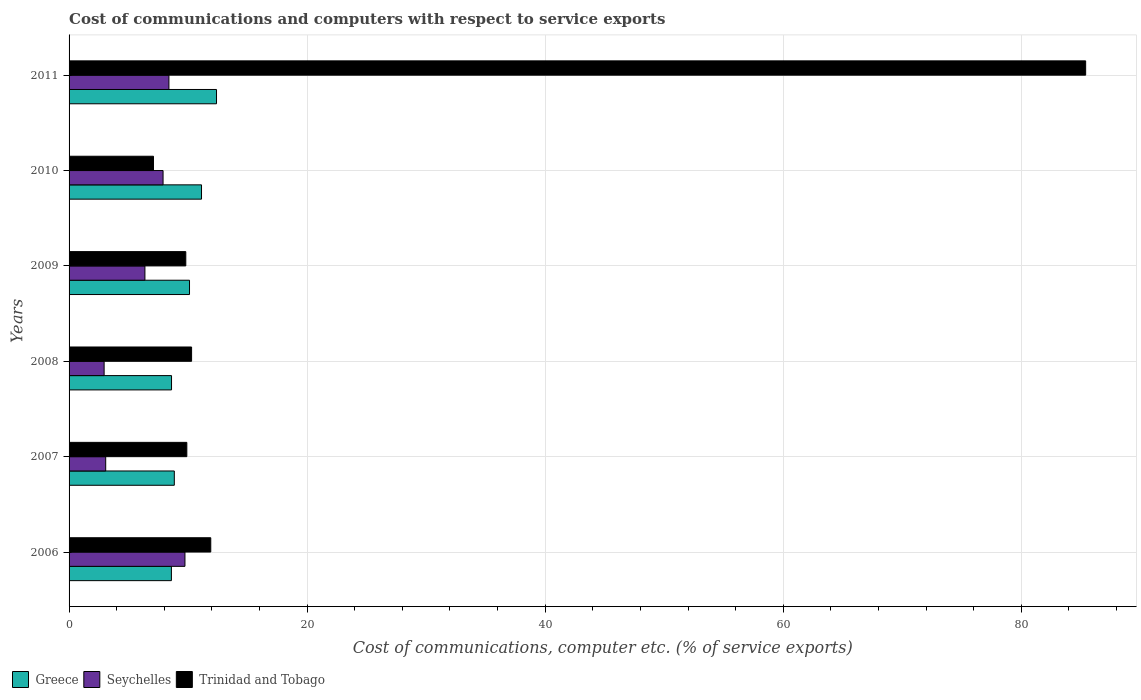How many groups of bars are there?
Make the answer very short. 6. Are the number of bars on each tick of the Y-axis equal?
Your answer should be compact. Yes. How many bars are there on the 6th tick from the top?
Your response must be concise. 3. How many bars are there on the 6th tick from the bottom?
Offer a very short reply. 3. What is the cost of communications and computers in Trinidad and Tobago in 2008?
Your answer should be compact. 10.29. Across all years, what is the maximum cost of communications and computers in Trinidad and Tobago?
Offer a very short reply. 85.41. Across all years, what is the minimum cost of communications and computers in Seychelles?
Make the answer very short. 2.95. In which year was the cost of communications and computers in Trinidad and Tobago maximum?
Provide a short and direct response. 2011. In which year was the cost of communications and computers in Greece minimum?
Your answer should be very brief. 2006. What is the total cost of communications and computers in Trinidad and Tobago in the graph?
Make the answer very short. 134.4. What is the difference between the cost of communications and computers in Trinidad and Tobago in 2006 and that in 2007?
Make the answer very short. 2.01. What is the difference between the cost of communications and computers in Greece in 2009 and the cost of communications and computers in Trinidad and Tobago in 2008?
Provide a succinct answer. -0.17. What is the average cost of communications and computers in Greece per year?
Provide a succinct answer. 9.95. In the year 2008, what is the difference between the cost of communications and computers in Seychelles and cost of communications and computers in Greece?
Your answer should be compact. -5.66. In how many years, is the cost of communications and computers in Greece greater than 60 %?
Your answer should be very brief. 0. What is the ratio of the cost of communications and computers in Trinidad and Tobago in 2006 to that in 2010?
Your answer should be compact. 1.68. What is the difference between the highest and the second highest cost of communications and computers in Seychelles?
Keep it short and to the point. 1.35. What is the difference between the highest and the lowest cost of communications and computers in Greece?
Ensure brevity in your answer.  3.79. In how many years, is the cost of communications and computers in Seychelles greater than the average cost of communications and computers in Seychelles taken over all years?
Your answer should be very brief. 3. What does the 1st bar from the top in 2011 represents?
Make the answer very short. Trinidad and Tobago. What does the 2nd bar from the bottom in 2011 represents?
Your response must be concise. Seychelles. Is it the case that in every year, the sum of the cost of communications and computers in Seychelles and cost of communications and computers in Greece is greater than the cost of communications and computers in Trinidad and Tobago?
Provide a short and direct response. No. How many bars are there?
Your answer should be compact. 18. Are all the bars in the graph horizontal?
Provide a short and direct response. Yes. How many years are there in the graph?
Keep it short and to the point. 6. Are the values on the major ticks of X-axis written in scientific E-notation?
Your answer should be very brief. No. Does the graph contain grids?
Provide a succinct answer. Yes. Where does the legend appear in the graph?
Provide a succinct answer. Bottom left. How are the legend labels stacked?
Offer a very short reply. Horizontal. What is the title of the graph?
Keep it short and to the point. Cost of communications and computers with respect to service exports. Does "Maldives" appear as one of the legend labels in the graph?
Give a very brief answer. No. What is the label or title of the X-axis?
Offer a terse response. Cost of communications, computer etc. (% of service exports). What is the label or title of the Y-axis?
Ensure brevity in your answer.  Years. What is the Cost of communications, computer etc. (% of service exports) in Greece in 2006?
Keep it short and to the point. 8.6. What is the Cost of communications, computer etc. (% of service exports) of Seychelles in 2006?
Your answer should be very brief. 9.74. What is the Cost of communications, computer etc. (% of service exports) in Trinidad and Tobago in 2006?
Provide a succinct answer. 11.9. What is the Cost of communications, computer etc. (% of service exports) of Greece in 2007?
Your answer should be compact. 8.84. What is the Cost of communications, computer etc. (% of service exports) in Seychelles in 2007?
Your response must be concise. 3.08. What is the Cost of communications, computer etc. (% of service exports) of Trinidad and Tobago in 2007?
Provide a succinct answer. 9.89. What is the Cost of communications, computer etc. (% of service exports) of Greece in 2008?
Offer a very short reply. 8.61. What is the Cost of communications, computer etc. (% of service exports) of Seychelles in 2008?
Provide a short and direct response. 2.95. What is the Cost of communications, computer etc. (% of service exports) in Trinidad and Tobago in 2008?
Offer a very short reply. 10.29. What is the Cost of communications, computer etc. (% of service exports) of Greece in 2009?
Make the answer very short. 10.12. What is the Cost of communications, computer etc. (% of service exports) of Seychelles in 2009?
Keep it short and to the point. 6.37. What is the Cost of communications, computer etc. (% of service exports) in Trinidad and Tobago in 2009?
Your answer should be very brief. 9.81. What is the Cost of communications, computer etc. (% of service exports) in Greece in 2010?
Make the answer very short. 11.13. What is the Cost of communications, computer etc. (% of service exports) of Seychelles in 2010?
Your response must be concise. 7.9. What is the Cost of communications, computer etc. (% of service exports) in Trinidad and Tobago in 2010?
Your answer should be compact. 7.09. What is the Cost of communications, computer etc. (% of service exports) in Greece in 2011?
Give a very brief answer. 12.39. What is the Cost of communications, computer etc. (% of service exports) in Seychelles in 2011?
Offer a very short reply. 8.39. What is the Cost of communications, computer etc. (% of service exports) in Trinidad and Tobago in 2011?
Your response must be concise. 85.41. Across all years, what is the maximum Cost of communications, computer etc. (% of service exports) in Greece?
Your answer should be compact. 12.39. Across all years, what is the maximum Cost of communications, computer etc. (% of service exports) in Seychelles?
Make the answer very short. 9.74. Across all years, what is the maximum Cost of communications, computer etc. (% of service exports) of Trinidad and Tobago?
Your answer should be compact. 85.41. Across all years, what is the minimum Cost of communications, computer etc. (% of service exports) in Greece?
Offer a terse response. 8.6. Across all years, what is the minimum Cost of communications, computer etc. (% of service exports) of Seychelles?
Your answer should be compact. 2.95. Across all years, what is the minimum Cost of communications, computer etc. (% of service exports) of Trinidad and Tobago?
Your answer should be compact. 7.09. What is the total Cost of communications, computer etc. (% of service exports) of Greece in the graph?
Offer a terse response. 59.68. What is the total Cost of communications, computer etc. (% of service exports) of Seychelles in the graph?
Offer a very short reply. 38.42. What is the total Cost of communications, computer etc. (% of service exports) in Trinidad and Tobago in the graph?
Keep it short and to the point. 134.4. What is the difference between the Cost of communications, computer etc. (% of service exports) of Greece in 2006 and that in 2007?
Your answer should be very brief. -0.24. What is the difference between the Cost of communications, computer etc. (% of service exports) of Seychelles in 2006 and that in 2007?
Your response must be concise. 6.66. What is the difference between the Cost of communications, computer etc. (% of service exports) in Trinidad and Tobago in 2006 and that in 2007?
Your answer should be very brief. 2.01. What is the difference between the Cost of communications, computer etc. (% of service exports) in Greece in 2006 and that in 2008?
Provide a short and direct response. -0.01. What is the difference between the Cost of communications, computer etc. (% of service exports) in Seychelles in 2006 and that in 2008?
Your answer should be very brief. 6.79. What is the difference between the Cost of communications, computer etc. (% of service exports) of Trinidad and Tobago in 2006 and that in 2008?
Keep it short and to the point. 1.61. What is the difference between the Cost of communications, computer etc. (% of service exports) of Greece in 2006 and that in 2009?
Keep it short and to the point. -1.52. What is the difference between the Cost of communications, computer etc. (% of service exports) of Seychelles in 2006 and that in 2009?
Give a very brief answer. 3.36. What is the difference between the Cost of communications, computer etc. (% of service exports) of Trinidad and Tobago in 2006 and that in 2009?
Keep it short and to the point. 2.1. What is the difference between the Cost of communications, computer etc. (% of service exports) in Greece in 2006 and that in 2010?
Offer a very short reply. -2.53. What is the difference between the Cost of communications, computer etc. (% of service exports) of Seychelles in 2006 and that in 2010?
Make the answer very short. 1.84. What is the difference between the Cost of communications, computer etc. (% of service exports) of Trinidad and Tobago in 2006 and that in 2010?
Make the answer very short. 4.81. What is the difference between the Cost of communications, computer etc. (% of service exports) of Greece in 2006 and that in 2011?
Your answer should be compact. -3.79. What is the difference between the Cost of communications, computer etc. (% of service exports) of Seychelles in 2006 and that in 2011?
Your answer should be compact. 1.35. What is the difference between the Cost of communications, computer etc. (% of service exports) of Trinidad and Tobago in 2006 and that in 2011?
Keep it short and to the point. -73.5. What is the difference between the Cost of communications, computer etc. (% of service exports) of Greece in 2007 and that in 2008?
Provide a succinct answer. 0.23. What is the difference between the Cost of communications, computer etc. (% of service exports) in Seychelles in 2007 and that in 2008?
Keep it short and to the point. 0.13. What is the difference between the Cost of communications, computer etc. (% of service exports) of Trinidad and Tobago in 2007 and that in 2008?
Your response must be concise. -0.4. What is the difference between the Cost of communications, computer etc. (% of service exports) in Greece in 2007 and that in 2009?
Offer a terse response. -1.28. What is the difference between the Cost of communications, computer etc. (% of service exports) in Seychelles in 2007 and that in 2009?
Keep it short and to the point. -3.29. What is the difference between the Cost of communications, computer etc. (% of service exports) in Trinidad and Tobago in 2007 and that in 2009?
Ensure brevity in your answer.  0.09. What is the difference between the Cost of communications, computer etc. (% of service exports) in Greece in 2007 and that in 2010?
Ensure brevity in your answer.  -2.29. What is the difference between the Cost of communications, computer etc. (% of service exports) in Seychelles in 2007 and that in 2010?
Provide a succinct answer. -4.82. What is the difference between the Cost of communications, computer etc. (% of service exports) of Trinidad and Tobago in 2007 and that in 2010?
Your answer should be very brief. 2.8. What is the difference between the Cost of communications, computer etc. (% of service exports) of Greece in 2007 and that in 2011?
Offer a very short reply. -3.55. What is the difference between the Cost of communications, computer etc. (% of service exports) in Seychelles in 2007 and that in 2011?
Ensure brevity in your answer.  -5.31. What is the difference between the Cost of communications, computer etc. (% of service exports) in Trinidad and Tobago in 2007 and that in 2011?
Provide a short and direct response. -75.52. What is the difference between the Cost of communications, computer etc. (% of service exports) of Greece in 2008 and that in 2009?
Provide a short and direct response. -1.51. What is the difference between the Cost of communications, computer etc. (% of service exports) of Seychelles in 2008 and that in 2009?
Offer a very short reply. -3.43. What is the difference between the Cost of communications, computer etc. (% of service exports) in Trinidad and Tobago in 2008 and that in 2009?
Keep it short and to the point. 0.49. What is the difference between the Cost of communications, computer etc. (% of service exports) of Greece in 2008 and that in 2010?
Your answer should be very brief. -2.52. What is the difference between the Cost of communications, computer etc. (% of service exports) in Seychelles in 2008 and that in 2010?
Your response must be concise. -4.95. What is the difference between the Cost of communications, computer etc. (% of service exports) of Trinidad and Tobago in 2008 and that in 2010?
Offer a terse response. 3.2. What is the difference between the Cost of communications, computer etc. (% of service exports) in Greece in 2008 and that in 2011?
Give a very brief answer. -3.78. What is the difference between the Cost of communications, computer etc. (% of service exports) of Seychelles in 2008 and that in 2011?
Provide a succinct answer. -5.44. What is the difference between the Cost of communications, computer etc. (% of service exports) of Trinidad and Tobago in 2008 and that in 2011?
Provide a short and direct response. -75.12. What is the difference between the Cost of communications, computer etc. (% of service exports) in Greece in 2009 and that in 2010?
Your answer should be compact. -1.01. What is the difference between the Cost of communications, computer etc. (% of service exports) of Seychelles in 2009 and that in 2010?
Keep it short and to the point. -1.52. What is the difference between the Cost of communications, computer etc. (% of service exports) in Trinidad and Tobago in 2009 and that in 2010?
Ensure brevity in your answer.  2.71. What is the difference between the Cost of communications, computer etc. (% of service exports) of Greece in 2009 and that in 2011?
Give a very brief answer. -2.27. What is the difference between the Cost of communications, computer etc. (% of service exports) in Seychelles in 2009 and that in 2011?
Ensure brevity in your answer.  -2.02. What is the difference between the Cost of communications, computer etc. (% of service exports) in Trinidad and Tobago in 2009 and that in 2011?
Your response must be concise. -75.6. What is the difference between the Cost of communications, computer etc. (% of service exports) of Greece in 2010 and that in 2011?
Offer a very short reply. -1.26. What is the difference between the Cost of communications, computer etc. (% of service exports) of Seychelles in 2010 and that in 2011?
Your response must be concise. -0.49. What is the difference between the Cost of communications, computer etc. (% of service exports) of Trinidad and Tobago in 2010 and that in 2011?
Offer a terse response. -78.32. What is the difference between the Cost of communications, computer etc. (% of service exports) in Greece in 2006 and the Cost of communications, computer etc. (% of service exports) in Seychelles in 2007?
Keep it short and to the point. 5.52. What is the difference between the Cost of communications, computer etc. (% of service exports) of Greece in 2006 and the Cost of communications, computer etc. (% of service exports) of Trinidad and Tobago in 2007?
Your answer should be compact. -1.3. What is the difference between the Cost of communications, computer etc. (% of service exports) of Seychelles in 2006 and the Cost of communications, computer etc. (% of service exports) of Trinidad and Tobago in 2007?
Provide a short and direct response. -0.16. What is the difference between the Cost of communications, computer etc. (% of service exports) in Greece in 2006 and the Cost of communications, computer etc. (% of service exports) in Seychelles in 2008?
Give a very brief answer. 5.65. What is the difference between the Cost of communications, computer etc. (% of service exports) in Greece in 2006 and the Cost of communications, computer etc. (% of service exports) in Trinidad and Tobago in 2008?
Your answer should be very brief. -1.7. What is the difference between the Cost of communications, computer etc. (% of service exports) of Seychelles in 2006 and the Cost of communications, computer etc. (% of service exports) of Trinidad and Tobago in 2008?
Keep it short and to the point. -0.56. What is the difference between the Cost of communications, computer etc. (% of service exports) of Greece in 2006 and the Cost of communications, computer etc. (% of service exports) of Seychelles in 2009?
Your answer should be very brief. 2.22. What is the difference between the Cost of communications, computer etc. (% of service exports) in Greece in 2006 and the Cost of communications, computer etc. (% of service exports) in Trinidad and Tobago in 2009?
Provide a short and direct response. -1.21. What is the difference between the Cost of communications, computer etc. (% of service exports) of Seychelles in 2006 and the Cost of communications, computer etc. (% of service exports) of Trinidad and Tobago in 2009?
Ensure brevity in your answer.  -0.07. What is the difference between the Cost of communications, computer etc. (% of service exports) of Greece in 2006 and the Cost of communications, computer etc. (% of service exports) of Seychelles in 2010?
Provide a short and direct response. 0.7. What is the difference between the Cost of communications, computer etc. (% of service exports) in Greece in 2006 and the Cost of communications, computer etc. (% of service exports) in Trinidad and Tobago in 2010?
Your answer should be very brief. 1.51. What is the difference between the Cost of communications, computer etc. (% of service exports) in Seychelles in 2006 and the Cost of communications, computer etc. (% of service exports) in Trinidad and Tobago in 2010?
Make the answer very short. 2.64. What is the difference between the Cost of communications, computer etc. (% of service exports) of Greece in 2006 and the Cost of communications, computer etc. (% of service exports) of Seychelles in 2011?
Ensure brevity in your answer.  0.21. What is the difference between the Cost of communications, computer etc. (% of service exports) in Greece in 2006 and the Cost of communications, computer etc. (% of service exports) in Trinidad and Tobago in 2011?
Your answer should be very brief. -76.81. What is the difference between the Cost of communications, computer etc. (% of service exports) in Seychelles in 2006 and the Cost of communications, computer etc. (% of service exports) in Trinidad and Tobago in 2011?
Your response must be concise. -75.67. What is the difference between the Cost of communications, computer etc. (% of service exports) in Greece in 2007 and the Cost of communications, computer etc. (% of service exports) in Seychelles in 2008?
Your answer should be compact. 5.9. What is the difference between the Cost of communications, computer etc. (% of service exports) of Greece in 2007 and the Cost of communications, computer etc. (% of service exports) of Trinidad and Tobago in 2008?
Your response must be concise. -1.45. What is the difference between the Cost of communications, computer etc. (% of service exports) in Seychelles in 2007 and the Cost of communications, computer etc. (% of service exports) in Trinidad and Tobago in 2008?
Give a very brief answer. -7.22. What is the difference between the Cost of communications, computer etc. (% of service exports) of Greece in 2007 and the Cost of communications, computer etc. (% of service exports) of Seychelles in 2009?
Your answer should be compact. 2.47. What is the difference between the Cost of communications, computer etc. (% of service exports) in Greece in 2007 and the Cost of communications, computer etc. (% of service exports) in Trinidad and Tobago in 2009?
Make the answer very short. -0.97. What is the difference between the Cost of communications, computer etc. (% of service exports) in Seychelles in 2007 and the Cost of communications, computer etc. (% of service exports) in Trinidad and Tobago in 2009?
Provide a succinct answer. -6.73. What is the difference between the Cost of communications, computer etc. (% of service exports) of Greece in 2007 and the Cost of communications, computer etc. (% of service exports) of Seychelles in 2010?
Ensure brevity in your answer.  0.94. What is the difference between the Cost of communications, computer etc. (% of service exports) in Greece in 2007 and the Cost of communications, computer etc. (% of service exports) in Trinidad and Tobago in 2010?
Your answer should be compact. 1.75. What is the difference between the Cost of communications, computer etc. (% of service exports) of Seychelles in 2007 and the Cost of communications, computer etc. (% of service exports) of Trinidad and Tobago in 2010?
Provide a succinct answer. -4.01. What is the difference between the Cost of communications, computer etc. (% of service exports) of Greece in 2007 and the Cost of communications, computer etc. (% of service exports) of Seychelles in 2011?
Keep it short and to the point. 0.45. What is the difference between the Cost of communications, computer etc. (% of service exports) in Greece in 2007 and the Cost of communications, computer etc. (% of service exports) in Trinidad and Tobago in 2011?
Your answer should be compact. -76.57. What is the difference between the Cost of communications, computer etc. (% of service exports) of Seychelles in 2007 and the Cost of communications, computer etc. (% of service exports) of Trinidad and Tobago in 2011?
Offer a terse response. -82.33. What is the difference between the Cost of communications, computer etc. (% of service exports) of Greece in 2008 and the Cost of communications, computer etc. (% of service exports) of Seychelles in 2009?
Provide a succinct answer. 2.24. What is the difference between the Cost of communications, computer etc. (% of service exports) in Greece in 2008 and the Cost of communications, computer etc. (% of service exports) in Trinidad and Tobago in 2009?
Offer a terse response. -1.2. What is the difference between the Cost of communications, computer etc. (% of service exports) of Seychelles in 2008 and the Cost of communications, computer etc. (% of service exports) of Trinidad and Tobago in 2009?
Keep it short and to the point. -6.86. What is the difference between the Cost of communications, computer etc. (% of service exports) in Greece in 2008 and the Cost of communications, computer etc. (% of service exports) in Seychelles in 2010?
Ensure brevity in your answer.  0.71. What is the difference between the Cost of communications, computer etc. (% of service exports) of Greece in 2008 and the Cost of communications, computer etc. (% of service exports) of Trinidad and Tobago in 2010?
Ensure brevity in your answer.  1.52. What is the difference between the Cost of communications, computer etc. (% of service exports) in Seychelles in 2008 and the Cost of communications, computer etc. (% of service exports) in Trinidad and Tobago in 2010?
Make the answer very short. -4.15. What is the difference between the Cost of communications, computer etc. (% of service exports) of Greece in 2008 and the Cost of communications, computer etc. (% of service exports) of Seychelles in 2011?
Offer a terse response. 0.22. What is the difference between the Cost of communications, computer etc. (% of service exports) of Greece in 2008 and the Cost of communications, computer etc. (% of service exports) of Trinidad and Tobago in 2011?
Provide a short and direct response. -76.8. What is the difference between the Cost of communications, computer etc. (% of service exports) in Seychelles in 2008 and the Cost of communications, computer etc. (% of service exports) in Trinidad and Tobago in 2011?
Keep it short and to the point. -82.46. What is the difference between the Cost of communications, computer etc. (% of service exports) of Greece in 2009 and the Cost of communications, computer etc. (% of service exports) of Seychelles in 2010?
Give a very brief answer. 2.22. What is the difference between the Cost of communications, computer etc. (% of service exports) in Greece in 2009 and the Cost of communications, computer etc. (% of service exports) in Trinidad and Tobago in 2010?
Offer a terse response. 3.03. What is the difference between the Cost of communications, computer etc. (% of service exports) in Seychelles in 2009 and the Cost of communications, computer etc. (% of service exports) in Trinidad and Tobago in 2010?
Offer a very short reply. -0.72. What is the difference between the Cost of communications, computer etc. (% of service exports) in Greece in 2009 and the Cost of communications, computer etc. (% of service exports) in Seychelles in 2011?
Provide a succinct answer. 1.73. What is the difference between the Cost of communications, computer etc. (% of service exports) in Greece in 2009 and the Cost of communications, computer etc. (% of service exports) in Trinidad and Tobago in 2011?
Make the answer very short. -75.29. What is the difference between the Cost of communications, computer etc. (% of service exports) of Seychelles in 2009 and the Cost of communications, computer etc. (% of service exports) of Trinidad and Tobago in 2011?
Your answer should be compact. -79.04. What is the difference between the Cost of communications, computer etc. (% of service exports) in Greece in 2010 and the Cost of communications, computer etc. (% of service exports) in Seychelles in 2011?
Keep it short and to the point. 2.74. What is the difference between the Cost of communications, computer etc. (% of service exports) of Greece in 2010 and the Cost of communications, computer etc. (% of service exports) of Trinidad and Tobago in 2011?
Ensure brevity in your answer.  -74.28. What is the difference between the Cost of communications, computer etc. (% of service exports) of Seychelles in 2010 and the Cost of communications, computer etc. (% of service exports) of Trinidad and Tobago in 2011?
Offer a terse response. -77.51. What is the average Cost of communications, computer etc. (% of service exports) of Greece per year?
Give a very brief answer. 9.95. What is the average Cost of communications, computer etc. (% of service exports) in Seychelles per year?
Your answer should be compact. 6.4. What is the average Cost of communications, computer etc. (% of service exports) of Trinidad and Tobago per year?
Offer a terse response. 22.4. In the year 2006, what is the difference between the Cost of communications, computer etc. (% of service exports) in Greece and Cost of communications, computer etc. (% of service exports) in Seychelles?
Your answer should be very brief. -1.14. In the year 2006, what is the difference between the Cost of communications, computer etc. (% of service exports) in Greece and Cost of communications, computer etc. (% of service exports) in Trinidad and Tobago?
Your answer should be compact. -3.31. In the year 2006, what is the difference between the Cost of communications, computer etc. (% of service exports) in Seychelles and Cost of communications, computer etc. (% of service exports) in Trinidad and Tobago?
Provide a succinct answer. -2.17. In the year 2007, what is the difference between the Cost of communications, computer etc. (% of service exports) in Greece and Cost of communications, computer etc. (% of service exports) in Seychelles?
Your answer should be very brief. 5.76. In the year 2007, what is the difference between the Cost of communications, computer etc. (% of service exports) in Greece and Cost of communications, computer etc. (% of service exports) in Trinidad and Tobago?
Your response must be concise. -1.05. In the year 2007, what is the difference between the Cost of communications, computer etc. (% of service exports) in Seychelles and Cost of communications, computer etc. (% of service exports) in Trinidad and Tobago?
Ensure brevity in your answer.  -6.82. In the year 2008, what is the difference between the Cost of communications, computer etc. (% of service exports) of Greece and Cost of communications, computer etc. (% of service exports) of Seychelles?
Your response must be concise. 5.66. In the year 2008, what is the difference between the Cost of communications, computer etc. (% of service exports) in Greece and Cost of communications, computer etc. (% of service exports) in Trinidad and Tobago?
Provide a short and direct response. -1.69. In the year 2008, what is the difference between the Cost of communications, computer etc. (% of service exports) of Seychelles and Cost of communications, computer etc. (% of service exports) of Trinidad and Tobago?
Make the answer very short. -7.35. In the year 2009, what is the difference between the Cost of communications, computer etc. (% of service exports) in Greece and Cost of communications, computer etc. (% of service exports) in Seychelles?
Ensure brevity in your answer.  3.75. In the year 2009, what is the difference between the Cost of communications, computer etc. (% of service exports) of Greece and Cost of communications, computer etc. (% of service exports) of Trinidad and Tobago?
Keep it short and to the point. 0.31. In the year 2009, what is the difference between the Cost of communications, computer etc. (% of service exports) of Seychelles and Cost of communications, computer etc. (% of service exports) of Trinidad and Tobago?
Keep it short and to the point. -3.43. In the year 2010, what is the difference between the Cost of communications, computer etc. (% of service exports) in Greece and Cost of communications, computer etc. (% of service exports) in Seychelles?
Give a very brief answer. 3.23. In the year 2010, what is the difference between the Cost of communications, computer etc. (% of service exports) of Greece and Cost of communications, computer etc. (% of service exports) of Trinidad and Tobago?
Keep it short and to the point. 4.04. In the year 2010, what is the difference between the Cost of communications, computer etc. (% of service exports) of Seychelles and Cost of communications, computer etc. (% of service exports) of Trinidad and Tobago?
Give a very brief answer. 0.8. In the year 2011, what is the difference between the Cost of communications, computer etc. (% of service exports) in Greece and Cost of communications, computer etc. (% of service exports) in Seychelles?
Offer a very short reply. 4. In the year 2011, what is the difference between the Cost of communications, computer etc. (% of service exports) in Greece and Cost of communications, computer etc. (% of service exports) in Trinidad and Tobago?
Your response must be concise. -73.02. In the year 2011, what is the difference between the Cost of communications, computer etc. (% of service exports) of Seychelles and Cost of communications, computer etc. (% of service exports) of Trinidad and Tobago?
Your answer should be very brief. -77.02. What is the ratio of the Cost of communications, computer etc. (% of service exports) in Greece in 2006 to that in 2007?
Ensure brevity in your answer.  0.97. What is the ratio of the Cost of communications, computer etc. (% of service exports) in Seychelles in 2006 to that in 2007?
Make the answer very short. 3.16. What is the ratio of the Cost of communications, computer etc. (% of service exports) in Trinidad and Tobago in 2006 to that in 2007?
Provide a succinct answer. 1.2. What is the ratio of the Cost of communications, computer etc. (% of service exports) of Greece in 2006 to that in 2008?
Offer a terse response. 1. What is the ratio of the Cost of communications, computer etc. (% of service exports) in Seychelles in 2006 to that in 2008?
Provide a short and direct response. 3.31. What is the ratio of the Cost of communications, computer etc. (% of service exports) in Trinidad and Tobago in 2006 to that in 2008?
Your response must be concise. 1.16. What is the ratio of the Cost of communications, computer etc. (% of service exports) in Greece in 2006 to that in 2009?
Keep it short and to the point. 0.85. What is the ratio of the Cost of communications, computer etc. (% of service exports) of Seychelles in 2006 to that in 2009?
Your answer should be very brief. 1.53. What is the ratio of the Cost of communications, computer etc. (% of service exports) of Trinidad and Tobago in 2006 to that in 2009?
Make the answer very short. 1.21. What is the ratio of the Cost of communications, computer etc. (% of service exports) in Greece in 2006 to that in 2010?
Keep it short and to the point. 0.77. What is the ratio of the Cost of communications, computer etc. (% of service exports) of Seychelles in 2006 to that in 2010?
Offer a very short reply. 1.23. What is the ratio of the Cost of communications, computer etc. (% of service exports) in Trinidad and Tobago in 2006 to that in 2010?
Provide a succinct answer. 1.68. What is the ratio of the Cost of communications, computer etc. (% of service exports) in Greece in 2006 to that in 2011?
Give a very brief answer. 0.69. What is the ratio of the Cost of communications, computer etc. (% of service exports) in Seychelles in 2006 to that in 2011?
Provide a succinct answer. 1.16. What is the ratio of the Cost of communications, computer etc. (% of service exports) in Trinidad and Tobago in 2006 to that in 2011?
Your answer should be compact. 0.14. What is the ratio of the Cost of communications, computer etc. (% of service exports) in Greece in 2007 to that in 2008?
Give a very brief answer. 1.03. What is the ratio of the Cost of communications, computer etc. (% of service exports) of Seychelles in 2007 to that in 2008?
Your answer should be very brief. 1.04. What is the ratio of the Cost of communications, computer etc. (% of service exports) of Trinidad and Tobago in 2007 to that in 2008?
Your response must be concise. 0.96. What is the ratio of the Cost of communications, computer etc. (% of service exports) in Greece in 2007 to that in 2009?
Offer a terse response. 0.87. What is the ratio of the Cost of communications, computer etc. (% of service exports) of Seychelles in 2007 to that in 2009?
Offer a very short reply. 0.48. What is the ratio of the Cost of communications, computer etc. (% of service exports) in Trinidad and Tobago in 2007 to that in 2009?
Your answer should be very brief. 1.01. What is the ratio of the Cost of communications, computer etc. (% of service exports) of Greece in 2007 to that in 2010?
Keep it short and to the point. 0.79. What is the ratio of the Cost of communications, computer etc. (% of service exports) of Seychelles in 2007 to that in 2010?
Provide a succinct answer. 0.39. What is the ratio of the Cost of communications, computer etc. (% of service exports) in Trinidad and Tobago in 2007 to that in 2010?
Your answer should be compact. 1.4. What is the ratio of the Cost of communications, computer etc. (% of service exports) of Greece in 2007 to that in 2011?
Provide a succinct answer. 0.71. What is the ratio of the Cost of communications, computer etc. (% of service exports) of Seychelles in 2007 to that in 2011?
Keep it short and to the point. 0.37. What is the ratio of the Cost of communications, computer etc. (% of service exports) in Trinidad and Tobago in 2007 to that in 2011?
Your answer should be very brief. 0.12. What is the ratio of the Cost of communications, computer etc. (% of service exports) of Greece in 2008 to that in 2009?
Keep it short and to the point. 0.85. What is the ratio of the Cost of communications, computer etc. (% of service exports) in Seychelles in 2008 to that in 2009?
Your answer should be compact. 0.46. What is the ratio of the Cost of communications, computer etc. (% of service exports) of Trinidad and Tobago in 2008 to that in 2009?
Ensure brevity in your answer.  1.05. What is the ratio of the Cost of communications, computer etc. (% of service exports) of Greece in 2008 to that in 2010?
Provide a short and direct response. 0.77. What is the ratio of the Cost of communications, computer etc. (% of service exports) of Seychelles in 2008 to that in 2010?
Offer a terse response. 0.37. What is the ratio of the Cost of communications, computer etc. (% of service exports) in Trinidad and Tobago in 2008 to that in 2010?
Ensure brevity in your answer.  1.45. What is the ratio of the Cost of communications, computer etc. (% of service exports) of Greece in 2008 to that in 2011?
Provide a succinct answer. 0.69. What is the ratio of the Cost of communications, computer etc. (% of service exports) of Seychelles in 2008 to that in 2011?
Give a very brief answer. 0.35. What is the ratio of the Cost of communications, computer etc. (% of service exports) of Trinidad and Tobago in 2008 to that in 2011?
Provide a short and direct response. 0.12. What is the ratio of the Cost of communications, computer etc. (% of service exports) of Greece in 2009 to that in 2010?
Your response must be concise. 0.91. What is the ratio of the Cost of communications, computer etc. (% of service exports) of Seychelles in 2009 to that in 2010?
Keep it short and to the point. 0.81. What is the ratio of the Cost of communications, computer etc. (% of service exports) in Trinidad and Tobago in 2009 to that in 2010?
Offer a terse response. 1.38. What is the ratio of the Cost of communications, computer etc. (% of service exports) of Greece in 2009 to that in 2011?
Provide a succinct answer. 0.82. What is the ratio of the Cost of communications, computer etc. (% of service exports) in Seychelles in 2009 to that in 2011?
Make the answer very short. 0.76. What is the ratio of the Cost of communications, computer etc. (% of service exports) in Trinidad and Tobago in 2009 to that in 2011?
Offer a terse response. 0.11. What is the ratio of the Cost of communications, computer etc. (% of service exports) in Greece in 2010 to that in 2011?
Provide a succinct answer. 0.9. What is the ratio of the Cost of communications, computer etc. (% of service exports) of Seychelles in 2010 to that in 2011?
Ensure brevity in your answer.  0.94. What is the ratio of the Cost of communications, computer etc. (% of service exports) of Trinidad and Tobago in 2010 to that in 2011?
Provide a short and direct response. 0.08. What is the difference between the highest and the second highest Cost of communications, computer etc. (% of service exports) of Greece?
Provide a short and direct response. 1.26. What is the difference between the highest and the second highest Cost of communications, computer etc. (% of service exports) of Seychelles?
Offer a very short reply. 1.35. What is the difference between the highest and the second highest Cost of communications, computer etc. (% of service exports) in Trinidad and Tobago?
Offer a terse response. 73.5. What is the difference between the highest and the lowest Cost of communications, computer etc. (% of service exports) in Greece?
Make the answer very short. 3.79. What is the difference between the highest and the lowest Cost of communications, computer etc. (% of service exports) of Seychelles?
Your response must be concise. 6.79. What is the difference between the highest and the lowest Cost of communications, computer etc. (% of service exports) in Trinidad and Tobago?
Keep it short and to the point. 78.32. 